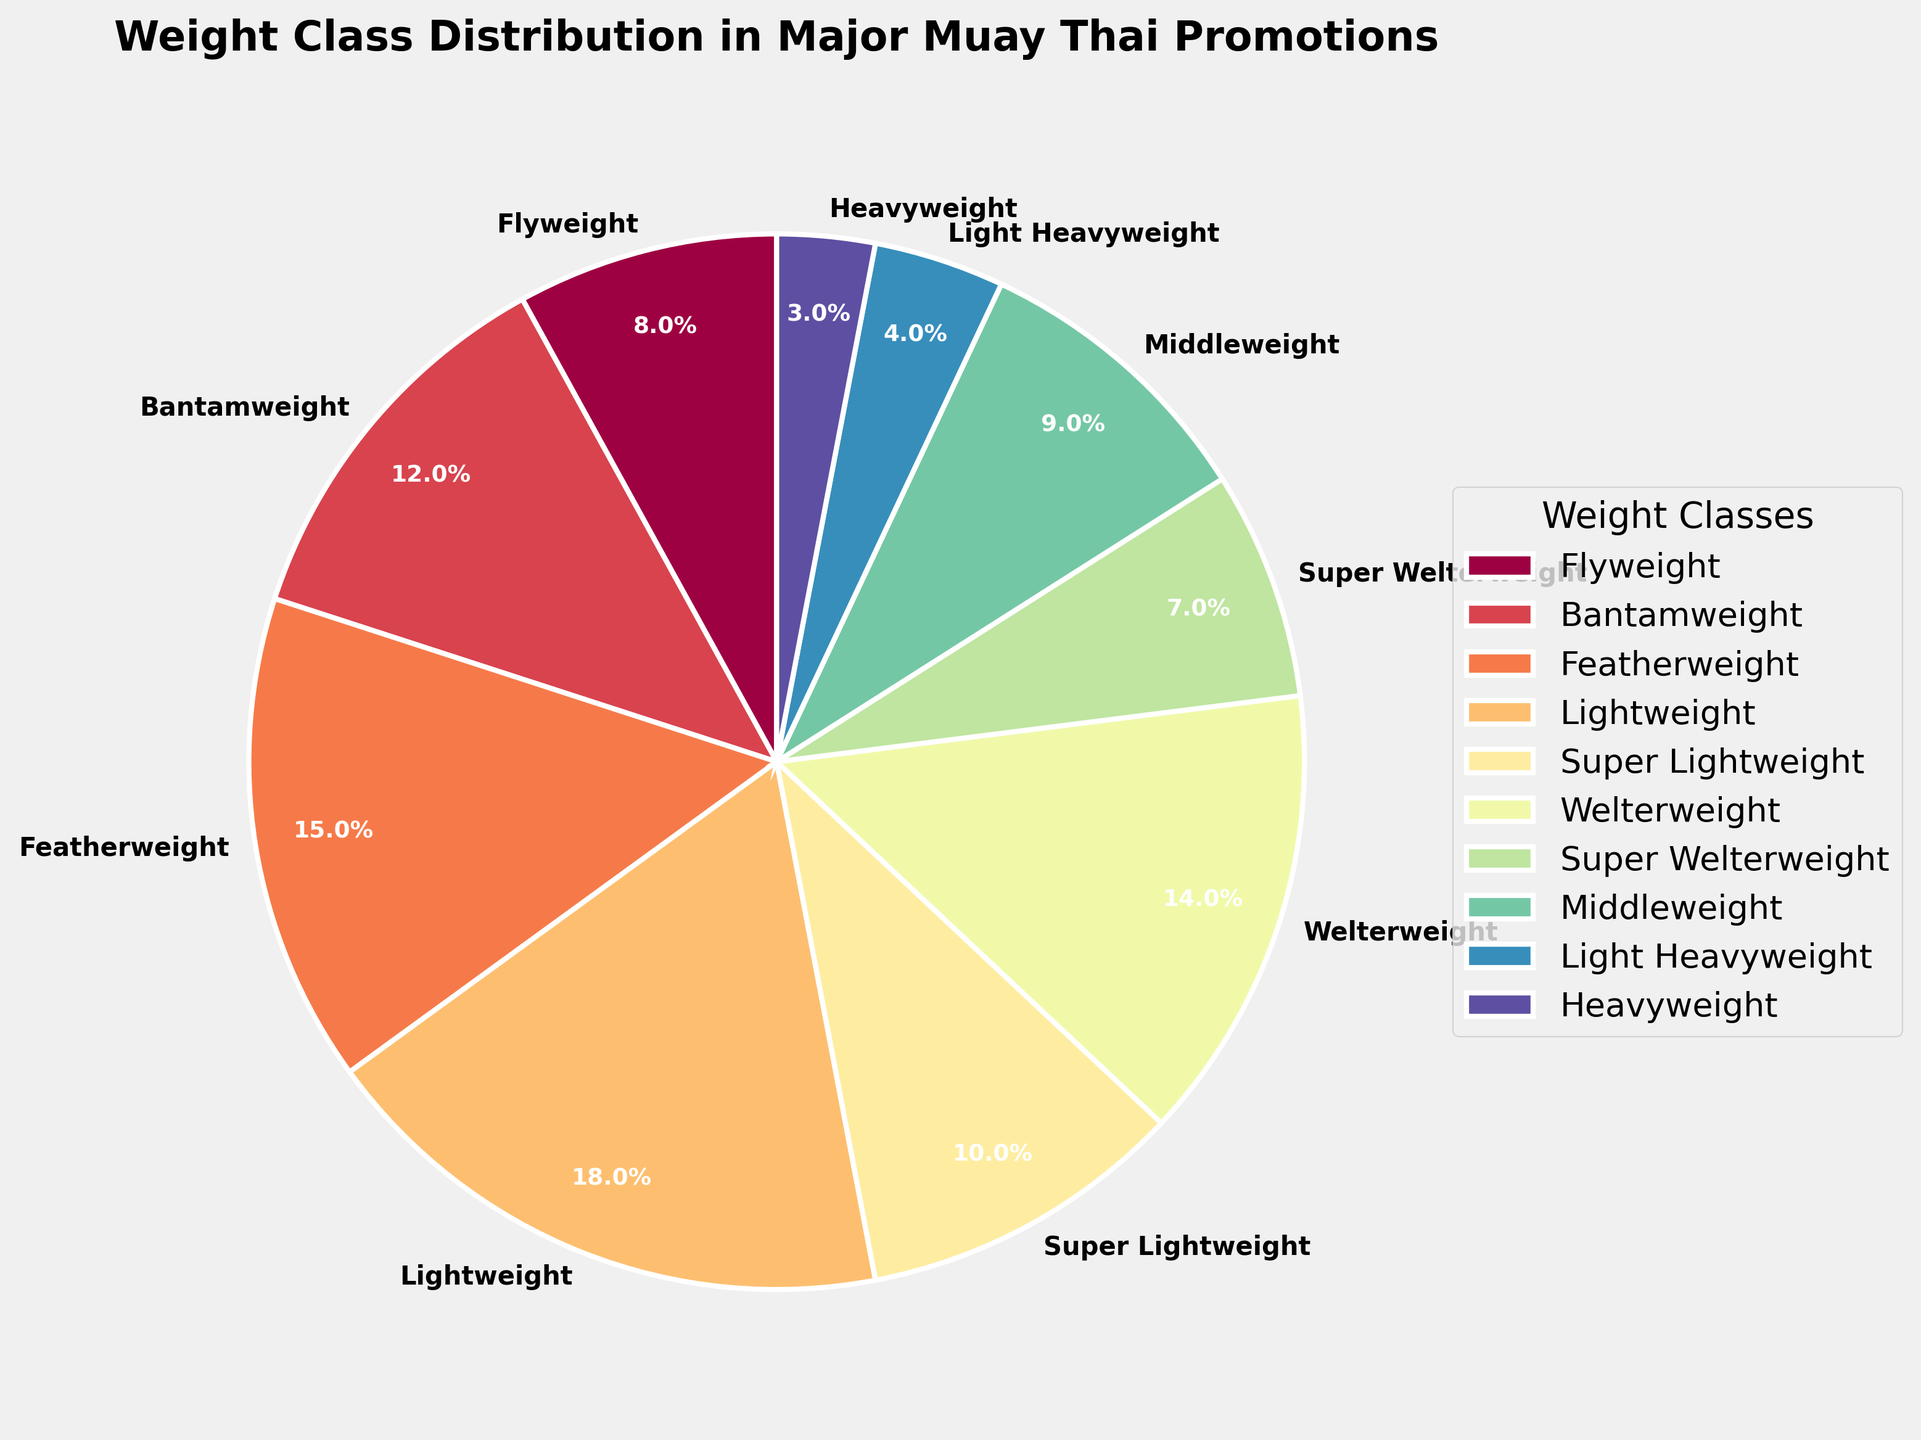What's the weight class with the highest percentage in major Muay Thai promotions? The weight class with the highest percentage can be directly inferred by looking at the largest slice of the pie chart and its label.
Answer: Lightweight (18%) Which weight classes together make up more than 25% of the distribution? Sum the percentages of the weight classes until the total exceeds 25%. Starting from the highest, Lightweight (18%) + Featherweight (15%) = 33%.
Answer: Lightweight and Featherweight What is the percentage difference between Welterweight and Super Welterweight? Find the slices labeled Welterweight and Super Welterweight, then calculate the difference in their percentages: 14% - 7% = 7%.
Answer: 7% Which three weight classes combined account for more than 40% of the total distribution? Sum the percentages of the highest three weight classes (Lightweight, Featherweight, and Welterweight): 18% + 15% + 14% = 47%.
Answer: Lightweight, Featherweight, and Welterweight What are the least represented weight classes in this promotion and their combined percentage? Identify the smallest slices and sum their percentages: Light Heavyweight (4%) and Heavyweight (3%). Combined, it is 4% + 3% = 7%.
Answer: Light Heavyweight and Heavyweight, 7% How much more represented is Middleweight compared to Heavyweight? Find the slices labeled Middleweight and Heavyweight and then calculate the difference in their percentages: Middleweight (9%) - Heavyweight (3%) = 6%.
Answer: 6% What is the total percentage represented by weight classes above Welterweight? Sum the percentages of all weight classes heavier than Welterweight: Super Welterweight (7%) + Middleweight (9%) + Light Heavyweight (4%) + Heavyweight (3%) = 23%.
Answer: 23% Which weight class is more represented: Bantamweight or Super Lightweight, and by how much? Calculate the difference between their percentages: Bantamweight (12%) - Super Lightweight (10%) = 2%.
Answer: Bantamweight, 2% Which weight classes make up less than 10% each? Identify the slices with percentages less than 10%: Flyweight (8%), Super Lightweight (10%), Super Welterweight (7%), Light Heavyweight (4%), and Heavyweight (3%).
Answer: Flyweight, Super Lightweight, Super Welterweight, Light Heavyweight, and Heavyweight 